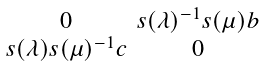<formula> <loc_0><loc_0><loc_500><loc_500>\begin{smallmatrix} 0 & s ( \lambda ) ^ { - 1 } s ( \mu ) b \\ s ( \lambda ) s ( \mu ) ^ { - 1 } c & 0 \end{smallmatrix}</formula> 